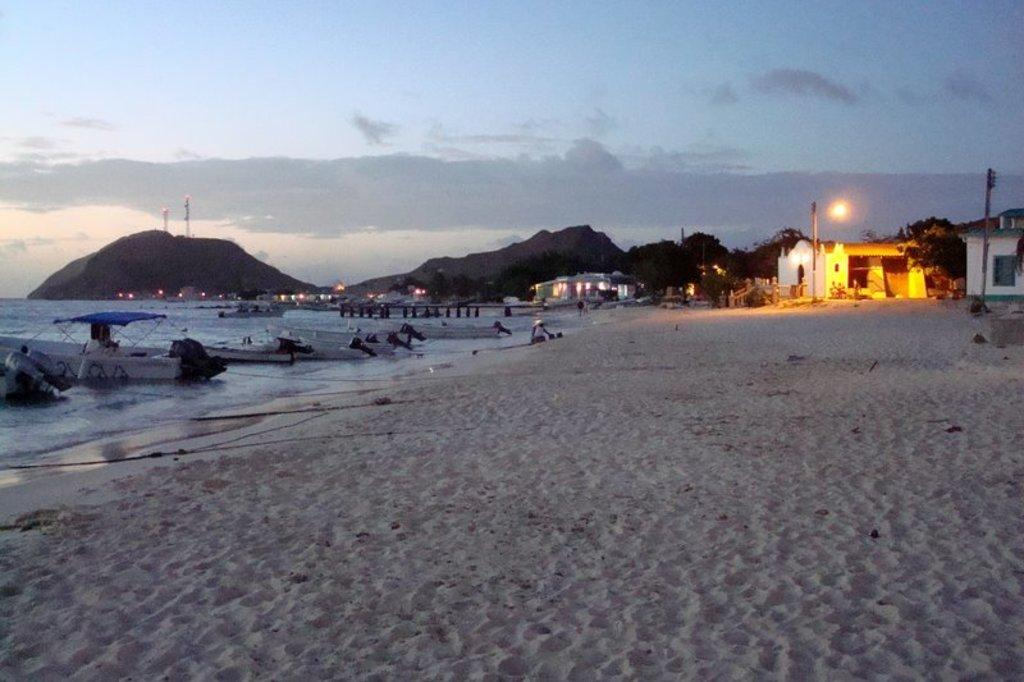What is the primary element visible in the image? There is water in the image. What types of vehicles can be seen in the image? There are boats in the image. What type of terrain is present in the image? There is sand in the image. What type of structures are visible in the image? There are houses in the image. What type of illumination is present in the image? There are lights in the image. What type of natural formation is visible in the image? There are hills in the image. What part of the natural environment is visible in the image? The sky is visible in the image. What type of weather can be inferred from the image? There are clouds in the image, which suggests that the weather might be partly cloudy. What type of quill can be seen in the image? There is no quill present in the image. How many letters are visible in the image? There is no letter present in the image. 